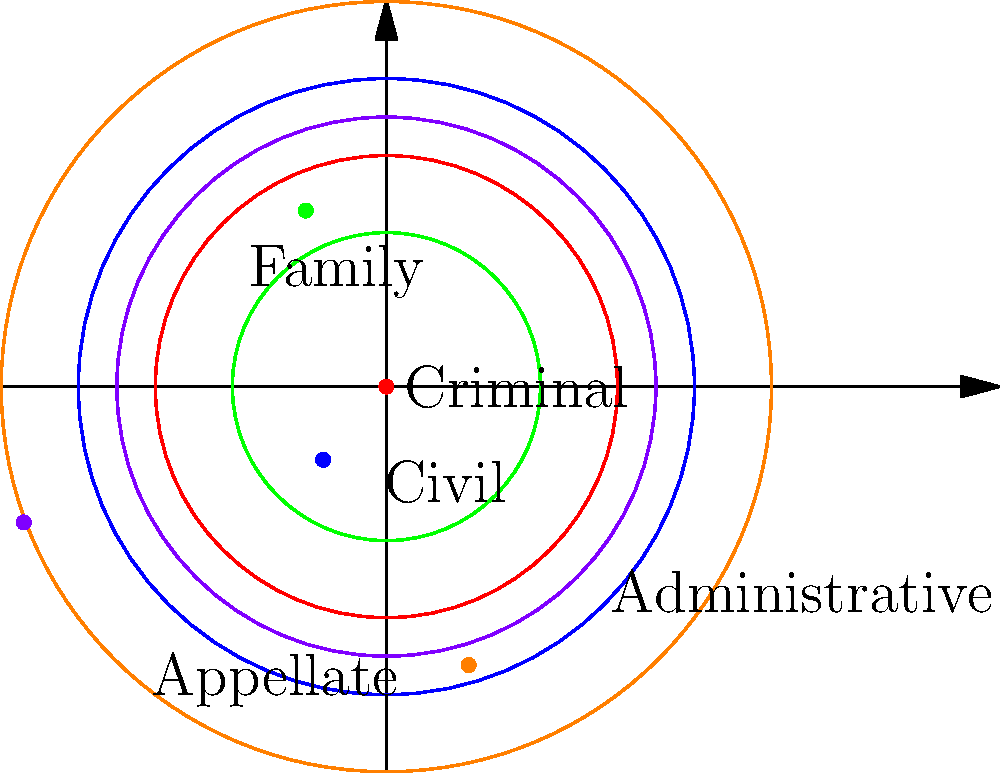In the polar area diagram above, which type of court case has the largest distribution in the given jurisdiction? To determine which type of court case has the largest distribution, we need to compare the areas of the circular sectors for each case type. In a polar area diagram, the area of each sector is proportional to the quantity it represents.

The area of a circular sector is given by the formula:
$$A = \frac{1}{2}r^2\theta$$

Where $r$ is the radius and $\theta$ is the angle in radians (which is constant for all sectors in this diagram).

Since $\theta$ is constant, we only need to compare the $r^2$ values:

1. Criminal: $r^2 = 3^2 = 9$
2. Civil: $r^2 = 4^2 = 16$
3. Family: $r^2 = 2^2 = 4$
4. Administrative: $r^2 = 5^2 = 25$
5. Appellate: $r^2 = 3.5^2 = 12.25$

The largest value is 25, corresponding to Administrative cases.
Answer: Administrative cases 